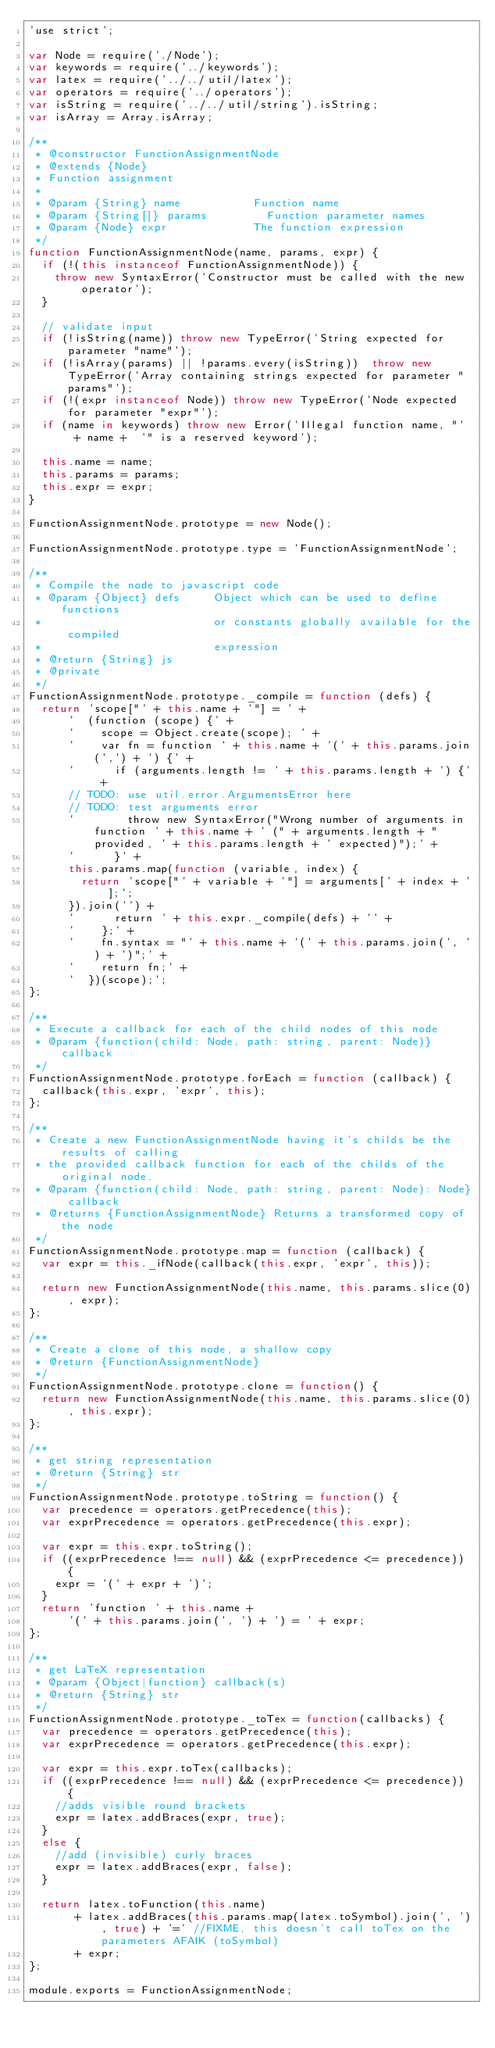<code> <loc_0><loc_0><loc_500><loc_500><_JavaScript_>'use strict';

var Node = require('./Node');
var keywords = require('../keywords');
var latex = require('../../util/latex');
var operators = require('../operators');
var isString = require('../../util/string').isString;
var isArray = Array.isArray;

/**
 * @constructor FunctionAssignmentNode
 * @extends {Node}
 * Function assignment
 *
 * @param {String} name           Function name
 * @param {String[]} params         Function parameter names
 * @param {Node} expr             The function expression
 */
function FunctionAssignmentNode(name, params, expr) {
  if (!(this instanceof FunctionAssignmentNode)) {
    throw new SyntaxError('Constructor must be called with the new operator');
  }

  // validate input
  if (!isString(name)) throw new TypeError('String expected for parameter "name"');
  if (!isArray(params) || !params.every(isString))  throw new TypeError('Array containing strings expected for parameter "params"');
  if (!(expr instanceof Node)) throw new TypeError('Node expected for parameter "expr"');
  if (name in keywords) throw new Error('Illegal function name, "'  + name +  '" is a reserved keyword');

  this.name = name;
  this.params = params;
  this.expr = expr;
}

FunctionAssignmentNode.prototype = new Node();

FunctionAssignmentNode.prototype.type = 'FunctionAssignmentNode';

/**
 * Compile the node to javascript code
 * @param {Object} defs     Object which can be used to define functions
 *                          or constants globally available for the compiled
 *                          expression
 * @return {String} js
 * @private
 */
FunctionAssignmentNode.prototype._compile = function (defs) {
  return 'scope["' + this.name + '"] = ' +
      '  (function (scope) {' +
      '    scope = Object.create(scope); ' +
      '    var fn = function ' + this.name + '(' + this.params.join(',') + ') {' +
      '      if (arguments.length != ' + this.params.length + ') {' +
      // TODO: use util.error.ArgumentsError here
      // TODO: test arguments error
      '        throw new SyntaxError("Wrong number of arguments in function ' + this.name + ' (" + arguments.length + " provided, ' + this.params.length + ' expected)");' +
      '      }' +
      this.params.map(function (variable, index) {
        return 'scope["' + variable + '"] = arguments[' + index + '];';
      }).join('') +
      '      return ' + this.expr._compile(defs) + '' +
      '    };' +
      '    fn.syntax = "' + this.name + '(' + this.params.join(', ') + ')";' +
      '    return fn;' +
      '  })(scope);';
};

/**
 * Execute a callback for each of the child nodes of this node
 * @param {function(child: Node, path: string, parent: Node)} callback
 */
FunctionAssignmentNode.prototype.forEach = function (callback) {
  callback(this.expr, 'expr', this);
};

/**
 * Create a new FunctionAssignmentNode having it's childs be the results of calling
 * the provided callback function for each of the childs of the original node.
 * @param {function(child: Node, path: string, parent: Node): Node} callback
 * @returns {FunctionAssignmentNode} Returns a transformed copy of the node
 */
FunctionAssignmentNode.prototype.map = function (callback) {
  var expr = this._ifNode(callback(this.expr, 'expr', this));

  return new FunctionAssignmentNode(this.name, this.params.slice(0), expr);
};

/**
 * Create a clone of this node, a shallow copy
 * @return {FunctionAssignmentNode}
 */
FunctionAssignmentNode.prototype.clone = function() {
  return new FunctionAssignmentNode(this.name, this.params.slice(0), this.expr);
};

/**
 * get string representation
 * @return {String} str
 */
FunctionAssignmentNode.prototype.toString = function() {
  var precedence = operators.getPrecedence(this);
  var exprPrecedence = operators.getPrecedence(this.expr);

  var expr = this.expr.toString();
  if ((exprPrecedence !== null) && (exprPrecedence <= precedence)) {
    expr = '(' + expr + ')';
  }
  return 'function ' + this.name +
      '(' + this.params.join(', ') + ') = ' + expr;
};

/**
 * get LaTeX representation
 * @param {Object|function} callback(s)
 * @return {String} str
 */
FunctionAssignmentNode.prototype._toTex = function(callbacks) {
  var precedence = operators.getPrecedence(this);
  var exprPrecedence = operators.getPrecedence(this.expr);

  var expr = this.expr.toTex(callbacks);
  if ((exprPrecedence !== null) && (exprPrecedence <= precedence)) {
    //adds visible round brackets
    expr = latex.addBraces(expr, true);
  }
  else {
    //add (invisible) curly braces
    expr = latex.addBraces(expr, false);
  }

  return latex.toFunction(this.name)
       + latex.addBraces(this.params.map(latex.toSymbol).join(', '), true) + '=' //FIXME, this doesn't call toTex on the parameters AFAIK (toSymbol)
       + expr;
};

module.exports = FunctionAssignmentNode;
</code> 